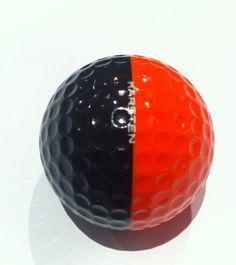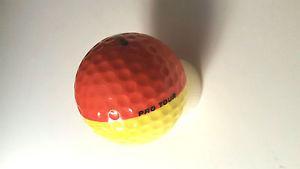The first image is the image on the left, the second image is the image on the right. Given the left and right images, does the statement "There are exactly two golf balls painted with half of one color and half of another color." hold true? Answer yes or no. Yes. The first image is the image on the left, the second image is the image on the right. Given the left and right images, does the statement "Atleast one image has a pure white ball" hold true? Answer yes or no. No. 